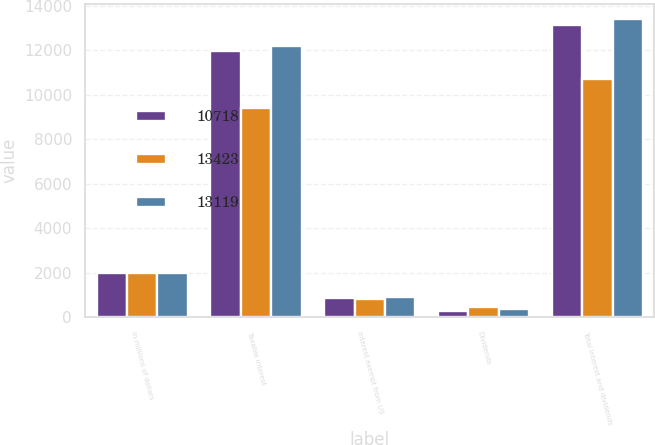Convert chart to OTSL. <chart><loc_0><loc_0><loc_500><loc_500><stacked_bar_chart><ecel><fcel>In millions of dollars<fcel>Taxable interest<fcel>Interest exempt from US<fcel>Dividends<fcel>Total interest and dividends<nl><fcel>10718<fcel>2009<fcel>11970<fcel>864<fcel>285<fcel>13119<nl><fcel>13423<fcel>2008<fcel>9407<fcel>836<fcel>475<fcel>10718<nl><fcel>13119<fcel>2007<fcel>12169<fcel>897<fcel>357<fcel>13423<nl></chart> 